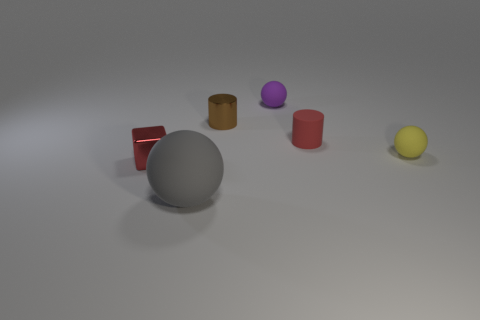Subtract all tiny balls. How many balls are left? 1 Add 2 small shiny blocks. How many objects exist? 8 Subtract all purple spheres. How many spheres are left? 2 Subtract 1 balls. How many balls are left? 2 Add 2 gray matte things. How many gray matte things are left? 3 Add 6 tiny yellow rubber balls. How many tiny yellow rubber balls exist? 7 Subtract 0 gray cylinders. How many objects are left? 6 Subtract all cubes. How many objects are left? 5 Subtract all blue balls. Subtract all green cylinders. How many balls are left? 3 Subtract all blue cubes. How many cyan cylinders are left? 0 